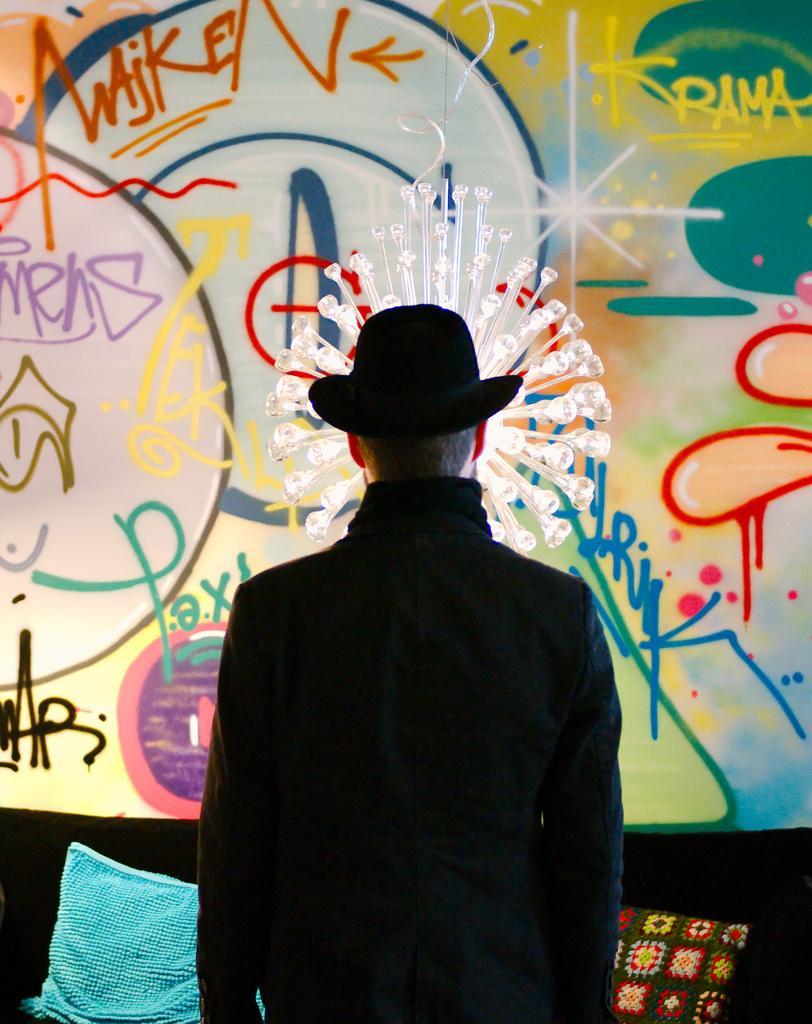Who is present in the image? There is a man in the image. What is the man wearing on his head? The man is wearing a black hat. What is the man wearing on his upper body? The man is wearing a black jacket. What type of furniture is in the image? There is a sofa in the image. What is on the sofa? There are pillows on the sofa. What is on the wall in the image? There is a painting on the wall. Can you tell me how many kittens are playing volleyball in the image? There are no kittens or volleyball present in the image. Who is the representative of the group in the image? There is no group or representative mentioned in the image; it only features a man. 